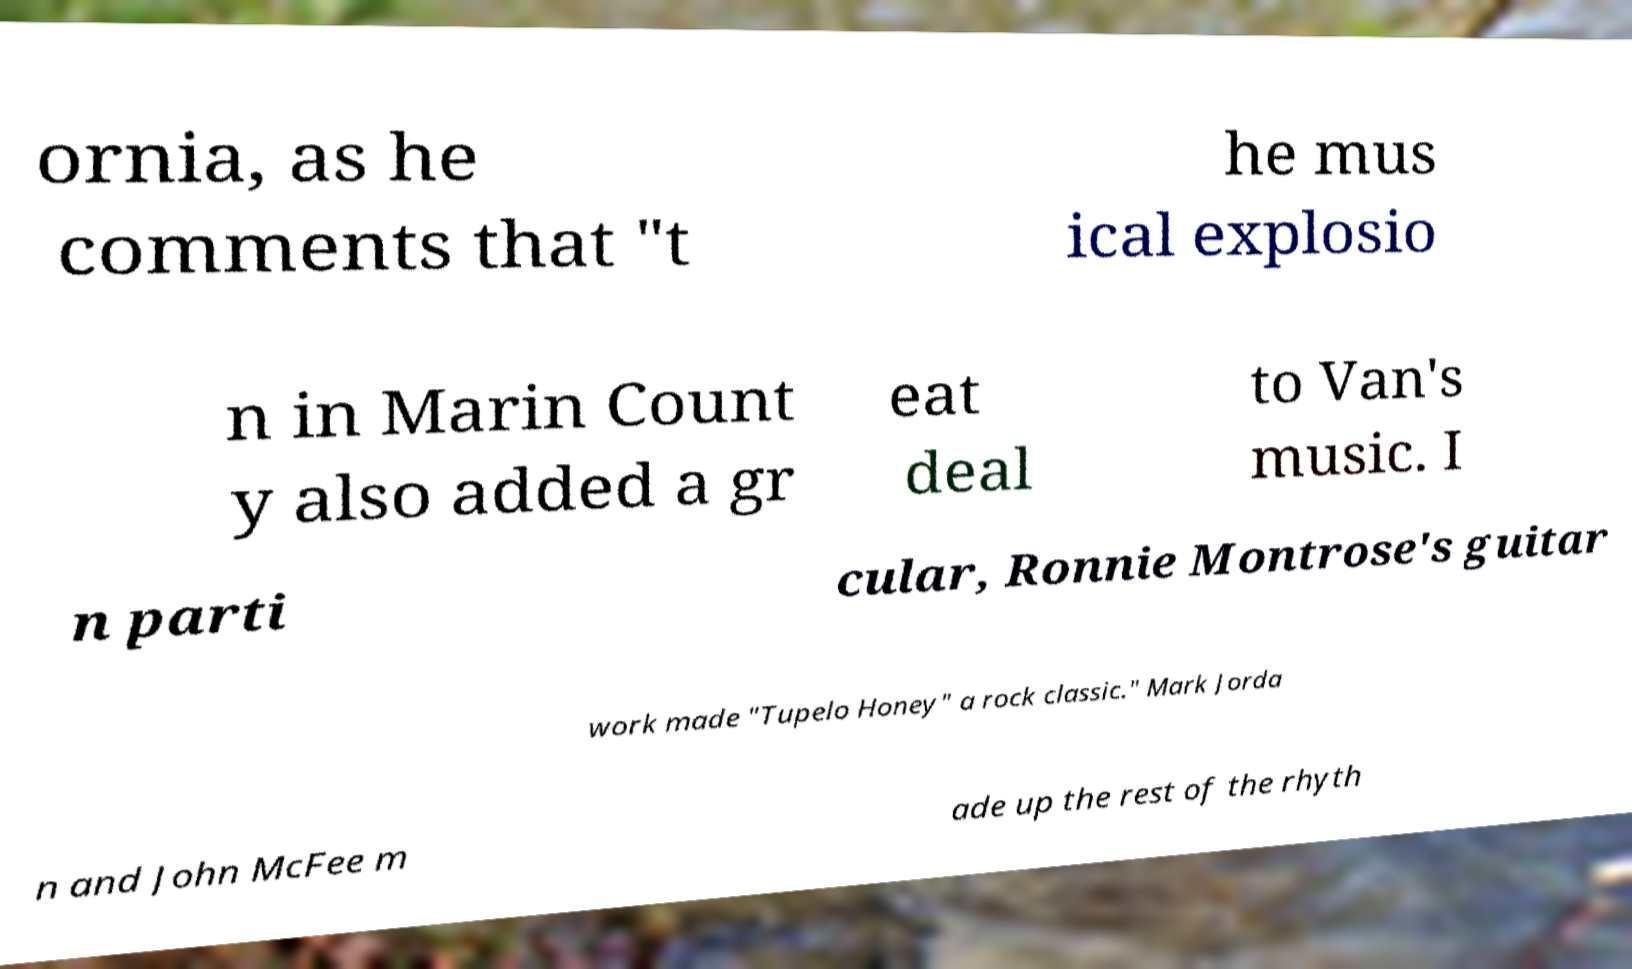I need the written content from this picture converted into text. Can you do that? ornia, as he comments that "t he mus ical explosio n in Marin Count y also added a gr eat deal to Van's music. I n parti cular, Ronnie Montrose's guitar work made "Tupelo Honey" a rock classic." Mark Jorda n and John McFee m ade up the rest of the rhyth 